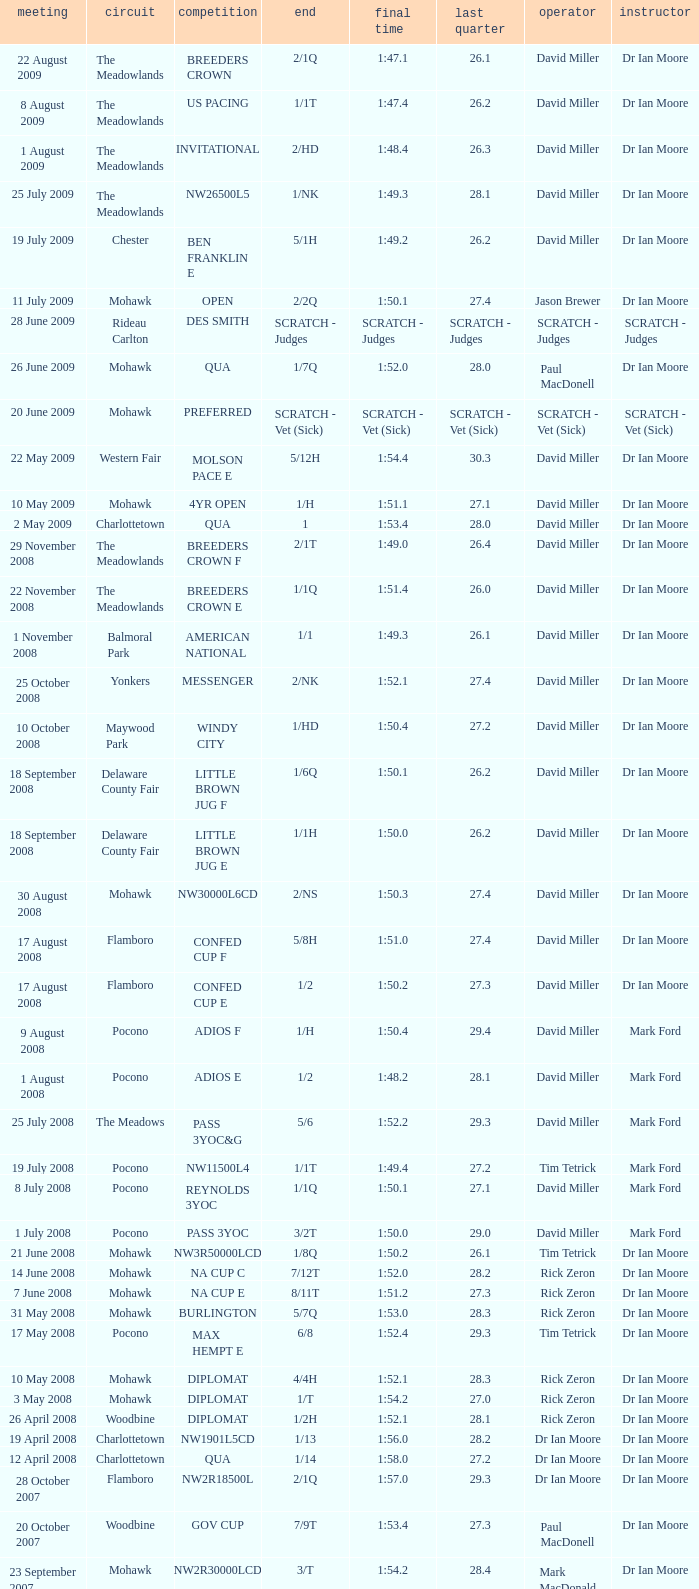What is the last 1/4 for the QUA race with a finishing time of 2:03.1? 29.2. 